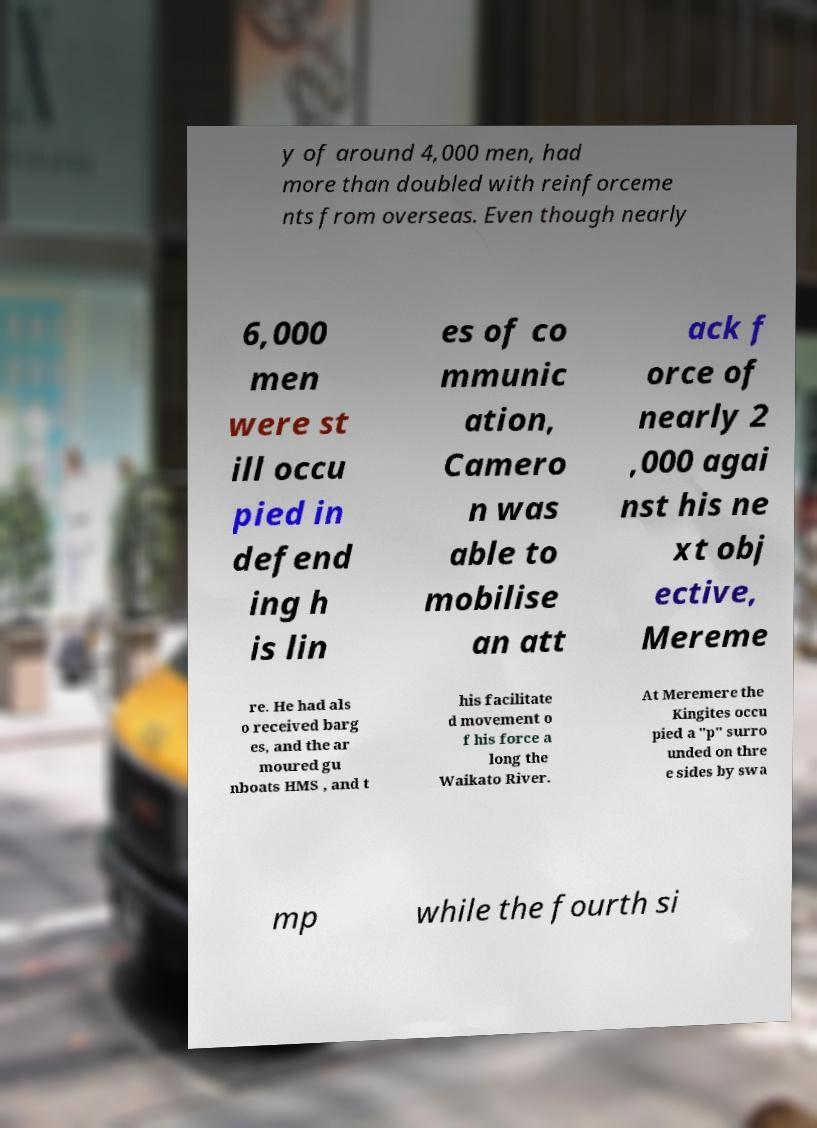Could you assist in decoding the text presented in this image and type it out clearly? y of around 4,000 men, had more than doubled with reinforceme nts from overseas. Even though nearly 6,000 men were st ill occu pied in defend ing h is lin es of co mmunic ation, Camero n was able to mobilise an att ack f orce of nearly 2 ,000 agai nst his ne xt obj ective, Mereme re. He had als o received barg es, and the ar moured gu nboats HMS , and t his facilitate d movement o f his force a long the Waikato River. At Meremere the Kingites occu pied a "p" surro unded on thre e sides by swa mp while the fourth si 